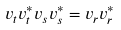Convert formula to latex. <formula><loc_0><loc_0><loc_500><loc_500>v _ { t } v _ { t } ^ { \ast } v _ { s } v _ { s } ^ { \ast } = v _ { r } v _ { r } ^ { \ast }</formula> 